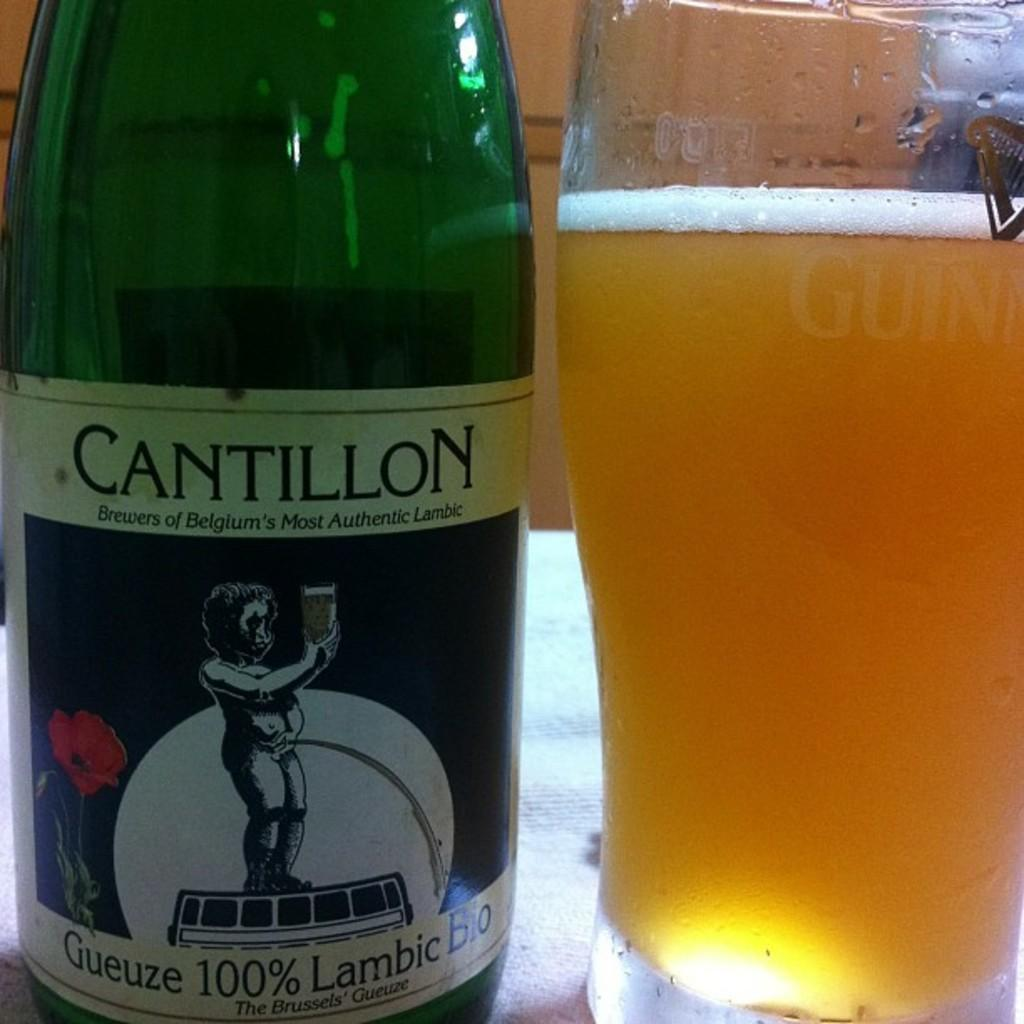Provide a one-sentence caption for the provided image. A bottle of Cantillon sits next to a glass of beer. 